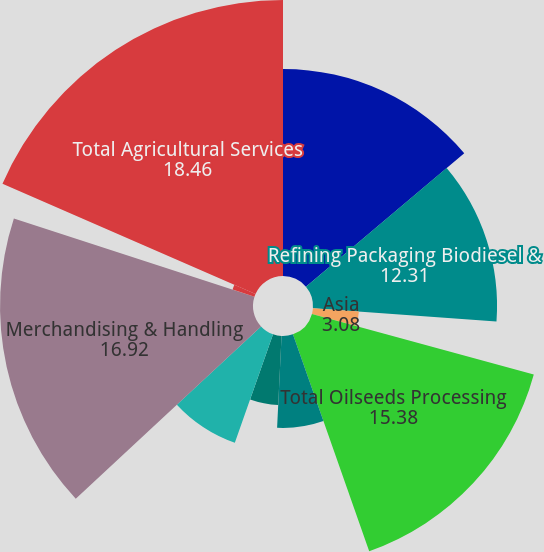Convert chart to OTSL. <chart><loc_0><loc_0><loc_500><loc_500><pie_chart><fcel>Crushing & Origination<fcel>Refining Packaging Biodiesel &<fcel>Asia<fcel>Total Oilseeds Processing<fcel>Sweeteners & Starches<fcel>Bioproducts<fcel>Total Corn Processing<fcel>Merchandising & Handling<fcel>Transportation<fcel>Total Agricultural Services<nl><fcel>13.85%<fcel>12.31%<fcel>3.08%<fcel>15.38%<fcel>6.15%<fcel>4.62%<fcel>7.69%<fcel>16.92%<fcel>1.54%<fcel>18.46%<nl></chart> 